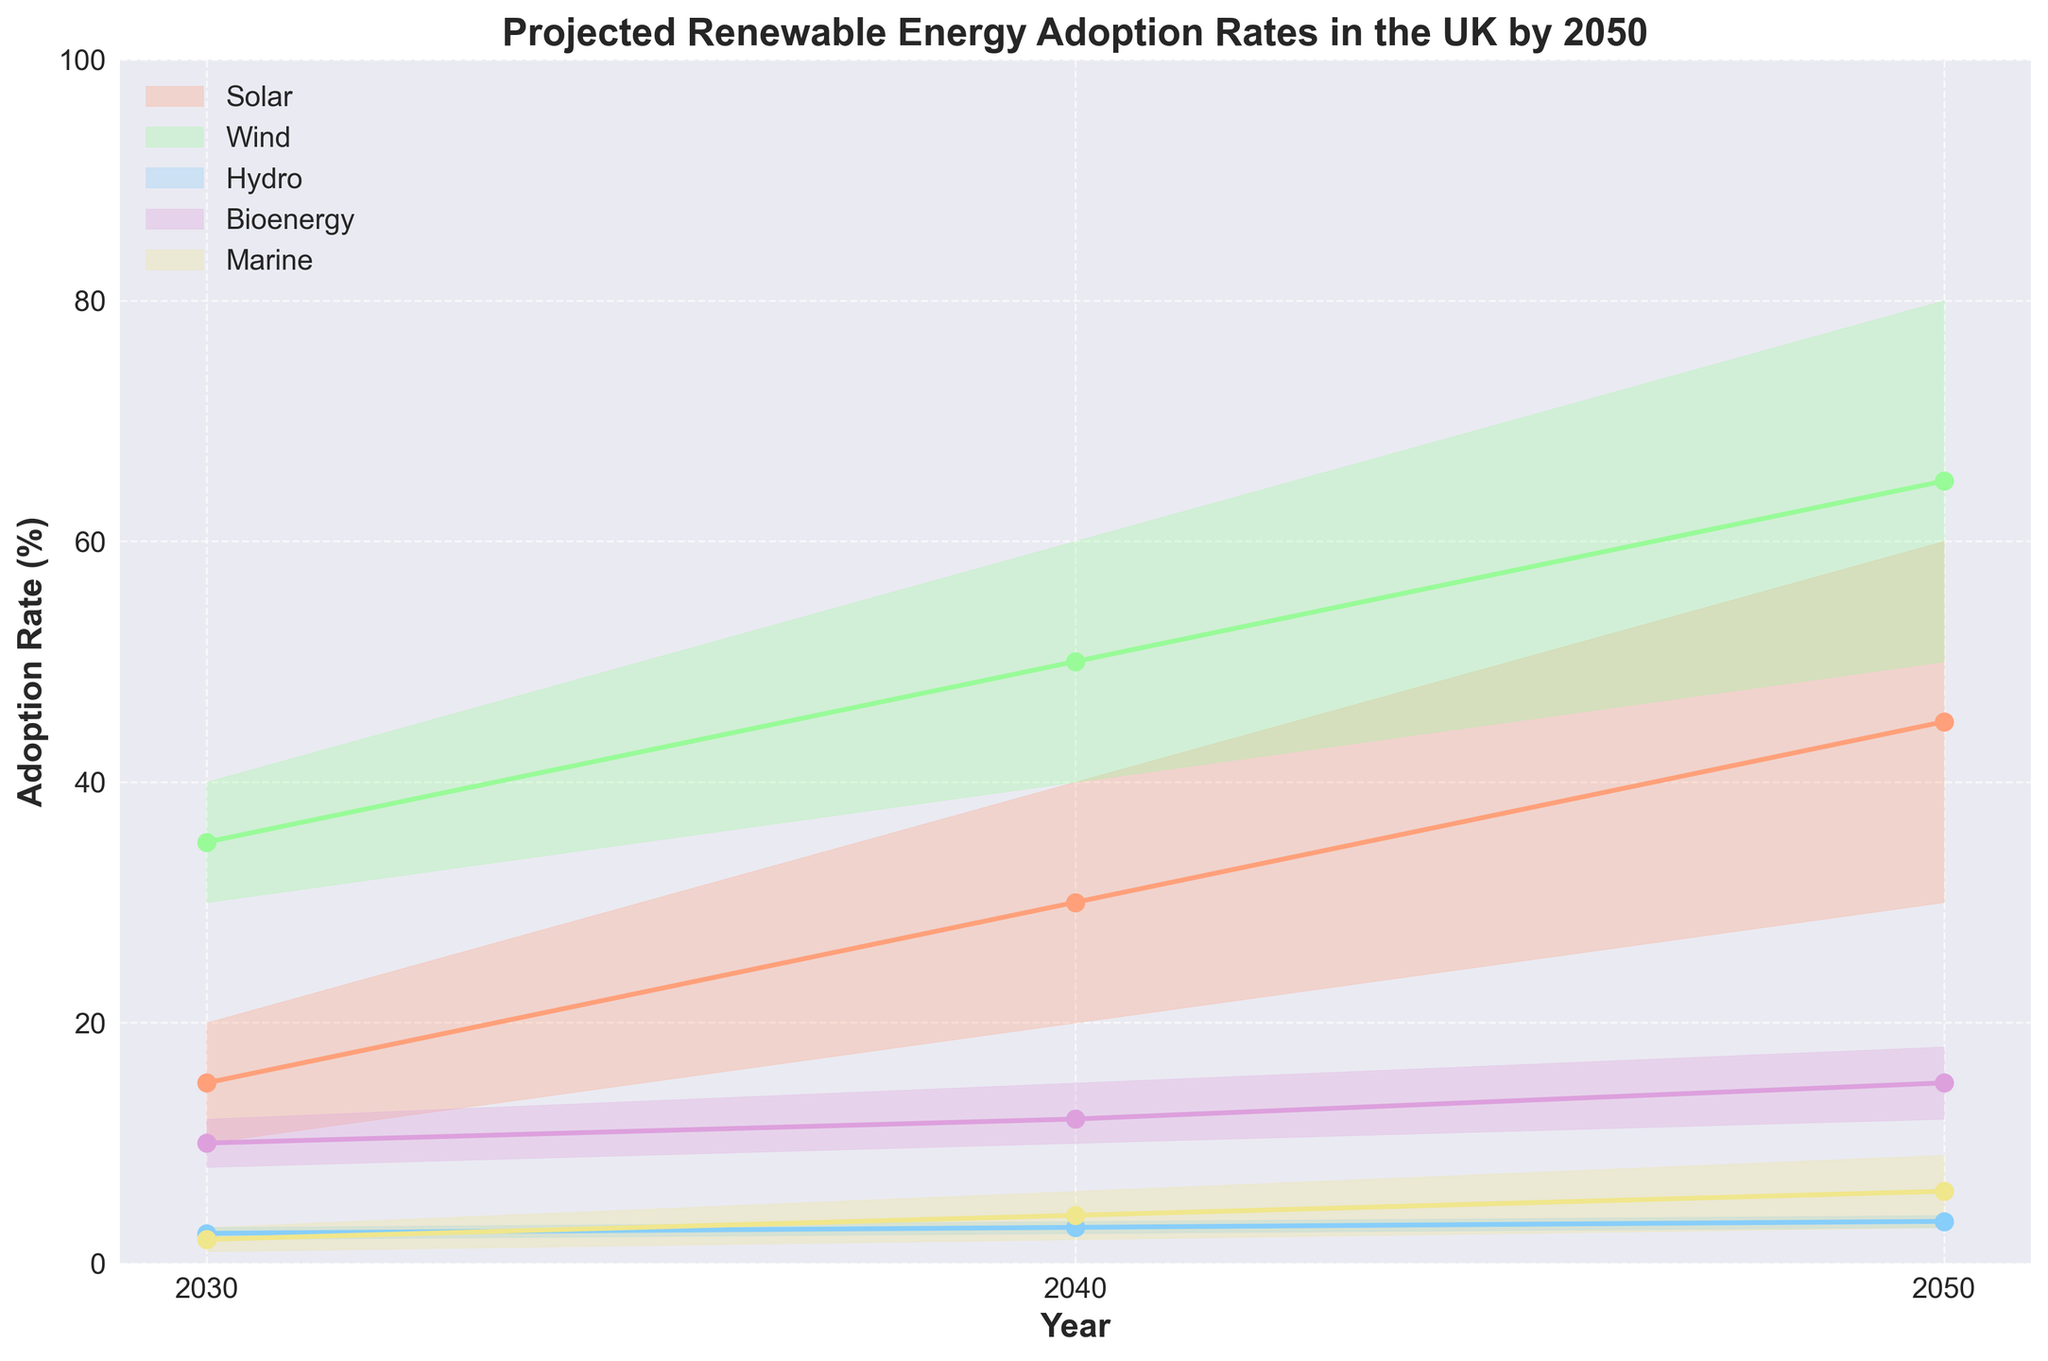What is the title of the figure? The title is displayed at the top of the chart in bold font. It summarizes the content of the chart.
Answer: Projected Renewable Energy Adoption Rates in the UK by 2050 Which renewable energy source is represented by the orange shade? The legend on the left-hand side of the chart provides the colors for each energy source. The orange color corresponds to the energy source listed in the legend.
Answer: Solar What are the adoption rates for Bioenergy in the Medium scenario in 2040? Locate the point corresponding to Bioenergy on the 2040 year line in the Medium scenario band.
Answer: 12% Which renewable energy source has the highest projected adoption rate in the High scenario for 2050? Examine the High scenario plot lines for 2050 and identify the energy source with the highest adoption rate.
Answer: Wind What is the projected range of adoption rates for Hydro in 2030? Look at the shaded area for Hydro in 2030 this will give the range from low to high scenario.
Answer: 2% to 3% How does the adoption rate of Marine energy change from 2030 to 2050 in the Medium scenario? Compare the adoption rates of Marine energy in the Medium scenario for the years 2030 and 2050.
Answer: It increases from 2% to 6% Which energy source shows the smallest rate of increase from 2030 to 2040 in the High scenario? Analyze the High scenario lines between 2030 and 2040 and find the source with the smallest difference.
Answer: Hydro What is the difference between the Low and High scenario adoption rates for Wind in 2040? Subtract the Low scenario adoption rate for Wind in 2040 from the High scenario adoption rate for Wind in the same year.
Answer: 20% Which energy source has the steepest slope between 2040 and 2050 in the High scenario? Look for the plot line with the most significant increase between these years in the High scenario.
Answer: Wind What are the adoption rates for Solar energy in the Low scenario across all years? Read off the adoption rates for Solar energy in the Low scenario for each year present in the chart.
Answer: 10%, 20%, 30% 